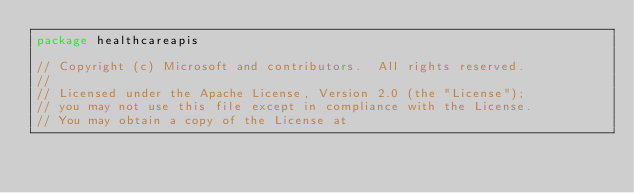Convert code to text. <code><loc_0><loc_0><loc_500><loc_500><_Go_>package healthcareapis

// Copyright (c) Microsoft and contributors.  All rights reserved.
//
// Licensed under the Apache License, Version 2.0 (the "License");
// you may not use this file except in compliance with the License.
// You may obtain a copy of the License at</code> 